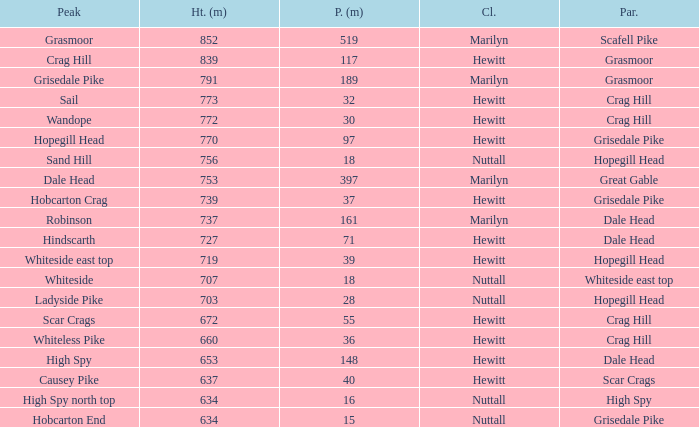What is the lowest height for Parent grasmoor when it has a Prom larger than 117? 791.0. 